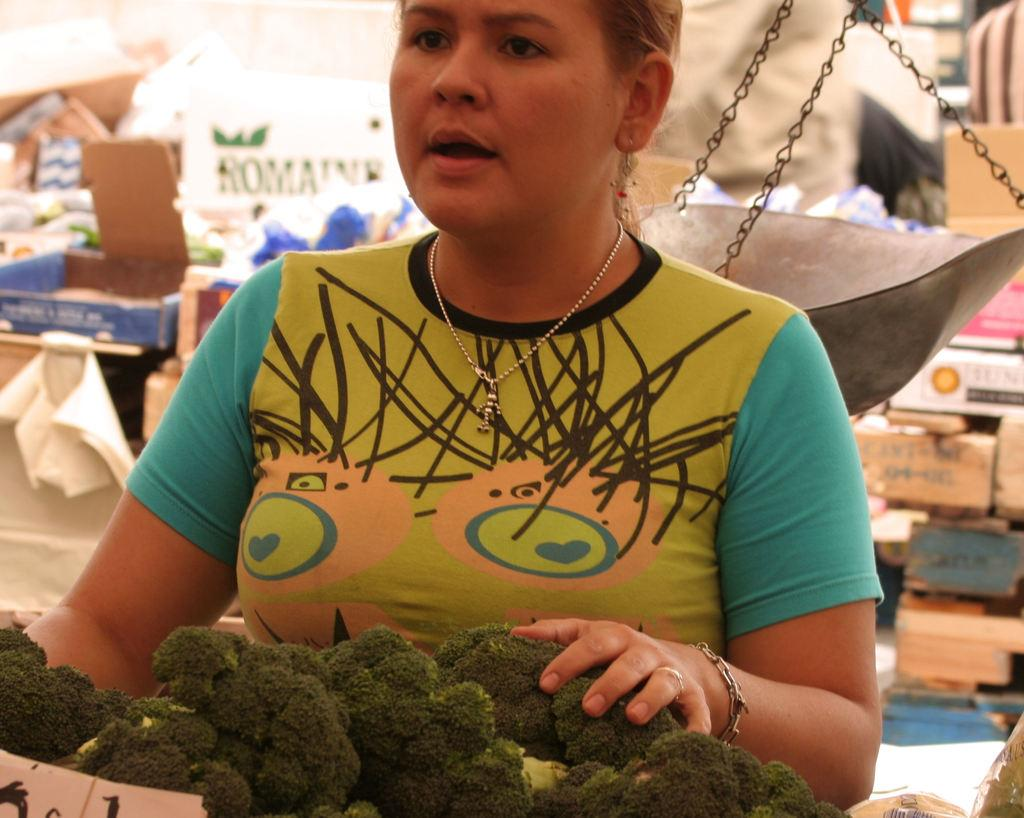What is the main subject of the image? There is a person standing in the image. What can be seen in the foreground of the image? There are vegetables in the foreground of the image. What object is present in the image that is used for measuring weight? There is a weighing machine in the image. What can be seen in the background of the image? There are many boxes in the background of the image. How many knots are tied on the vegetables in the image? There are no knots tied on the vegetables in the image, as knots are not related to vegetables. 